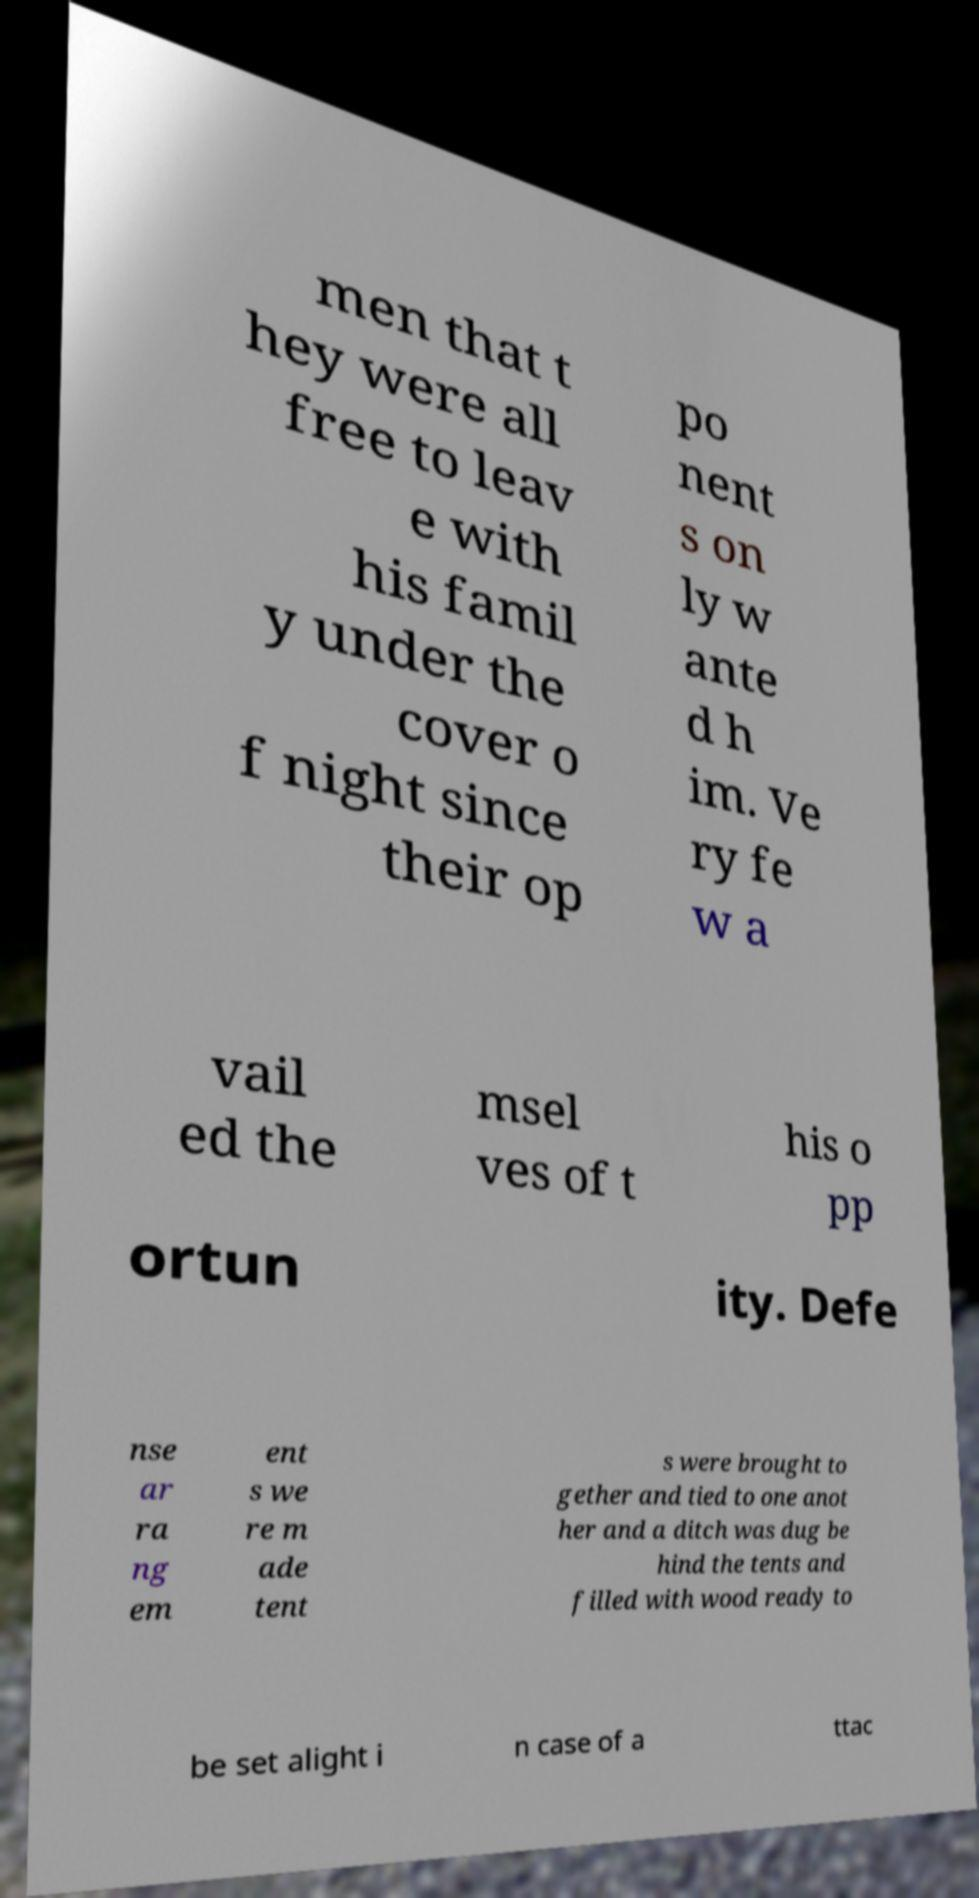Please read and relay the text visible in this image. What does it say? men that t hey were all free to leav e with his famil y under the cover o f night since their op po nent s on ly w ante d h im. Ve ry fe w a vail ed the msel ves of t his o pp ortun ity. Defe nse ar ra ng em ent s we re m ade tent s were brought to gether and tied to one anot her and a ditch was dug be hind the tents and filled with wood ready to be set alight i n case of a ttac 